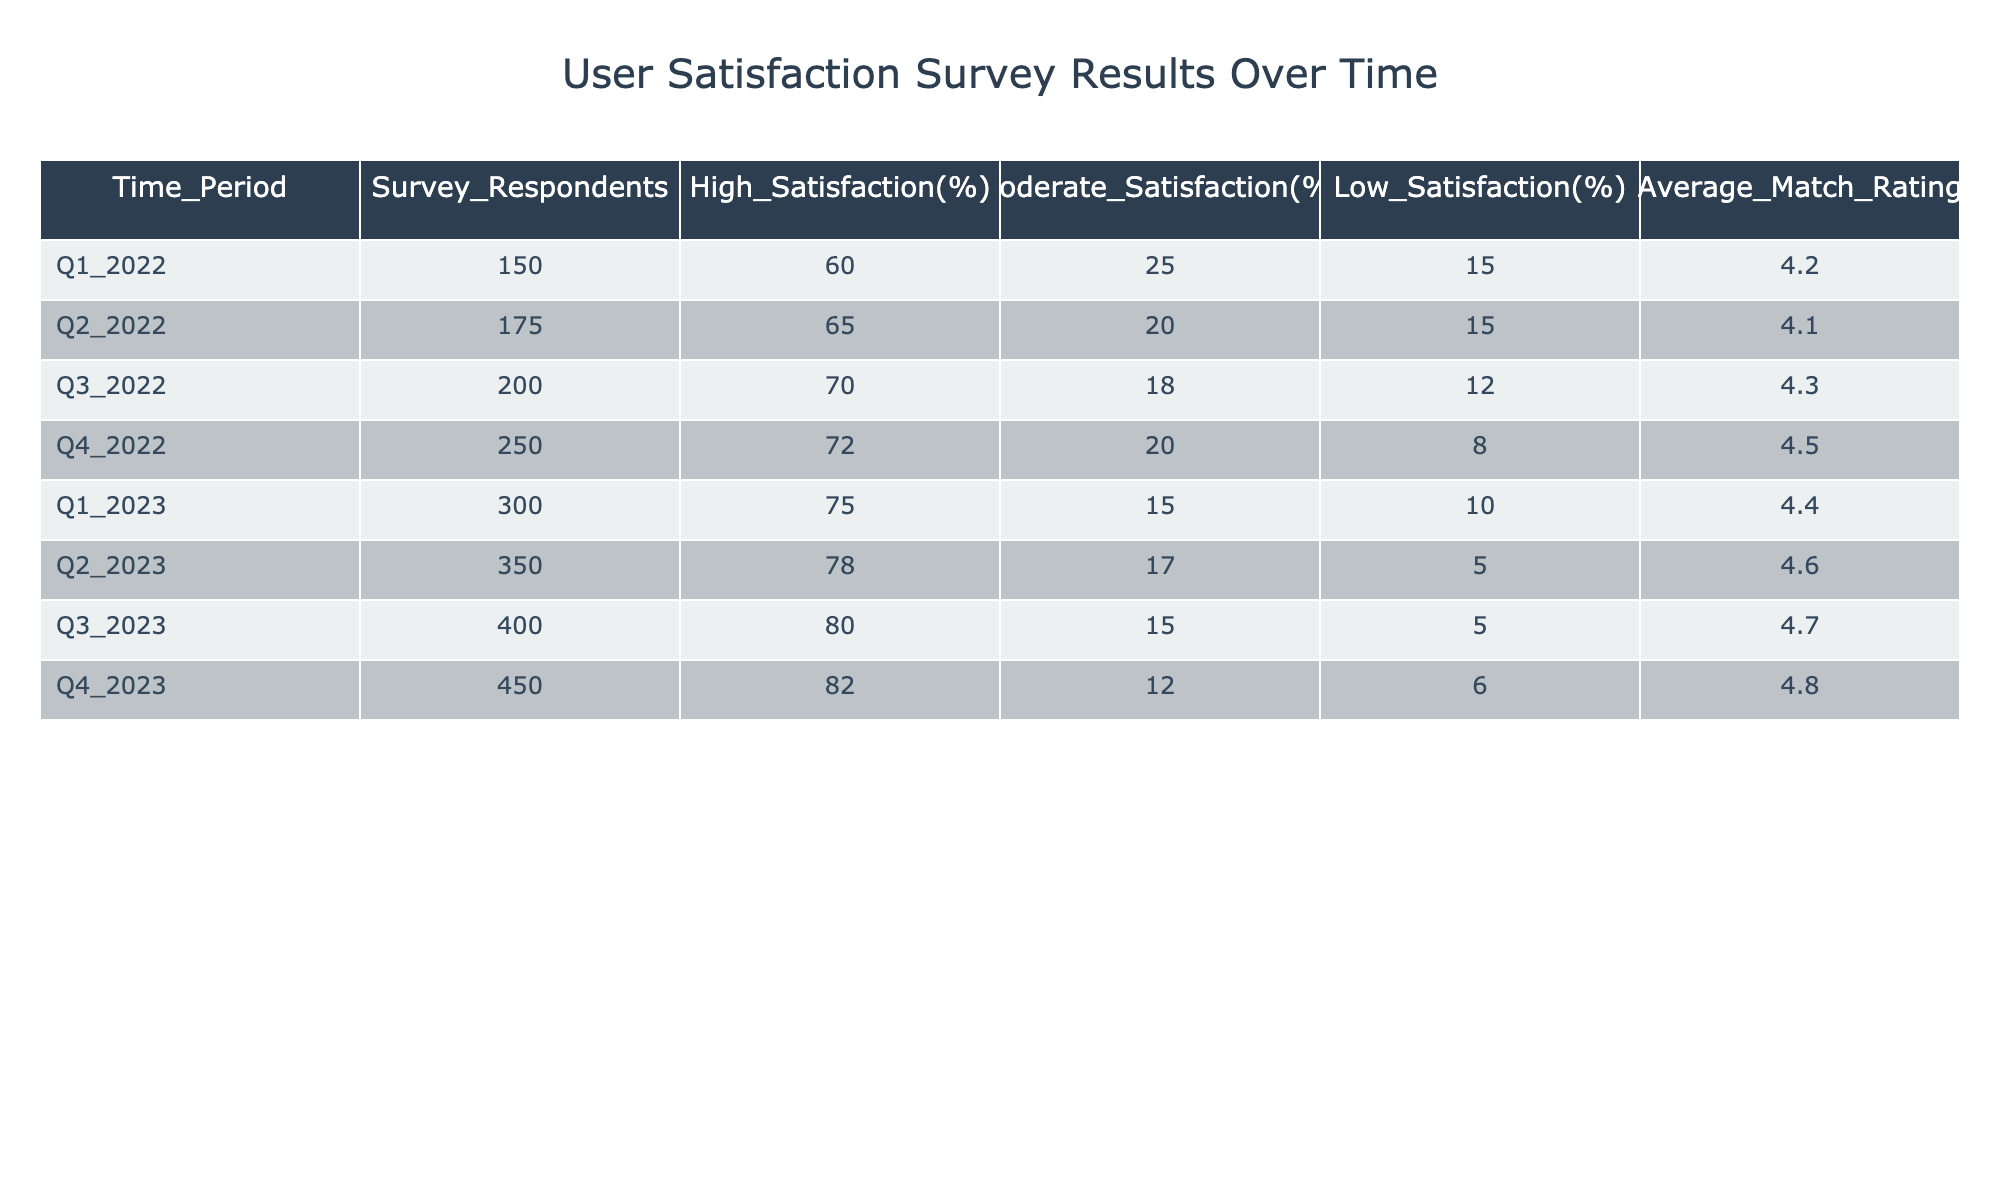What was the highest percentage of respondents reporting high satisfaction in 2023? In 2023, we look at each quarter's high satisfaction percentage: Q1 shows 75%, Q2 shows 78%, Q3 shows 80%, and Q4 shows 82%. The highest value among these is 82% in Q4 2023.
Answer: 82% How many total survey respondents were there in Q3 2022 and Q4 2022 combined? To find the total, we sum the survey respondents for Q3 2022 (200) and Q4 2022 (250): 200 + 250 = 450.
Answer: 450 Is the average match rating higher in Q2 2023 compared to Q3 2022? The average match rating for Q2 2023 is 4.6, and for Q3 2022, it is 4.3. Since 4.6 is greater than 4.3, the statement is true.
Answer: Yes What was the change in low satisfaction percentage from Q1 2022 to Q3 2023? In Q1 2022, the low satisfaction percentage was 15%, and in Q3 2023 it was 5%. The change is calculated as 15% - 5% = 10%. This is a decrease of 10%.
Answer: Decrease of 10% What was the average match rating for the year 2022? We calculate the average match rating for all quarters in 2022: (4.2 + 4.1 + 4.3 + 4.5) / 4 = 4.275. So the average for 2022 is approximately 4.3 when rounded.
Answer: 4.3 Did the percentage of respondents reporting moderate satisfaction decrease from Q1 2022 to Q4 2023? In Q1 2022, the percentage for moderate satisfaction was 25%, and in Q4 2023 it is 12%. Since 12% is less than 25%, the percentage did decrease.
Answer: Yes What quarter had the lowest percentage of low satisfaction respondents, and what was that percentage? Looking through the table, Q4 2022 had the lowest low satisfaction percentage at 8%.
Answer: Q4 2022, 8% How much did the high satisfaction percentage increase from the beginning of 2022 to the end of 2023? At the start of 2022 (Q1), high satisfaction was 60% and at the end of 2023 (Q4), it was 82%. The increase is 82% - 60% = 22%.
Answer: Increase of 22% What is the average percentage of high satisfaction over the entire surveyed period? To find the average, we add the high satisfaction percentages: (60 + 65 + 70 + 72 + 75 + 78 + 80 + 82) = 612. There are 8 data points, so 612 / 8 = 76.5%.
Answer: 76.5% 